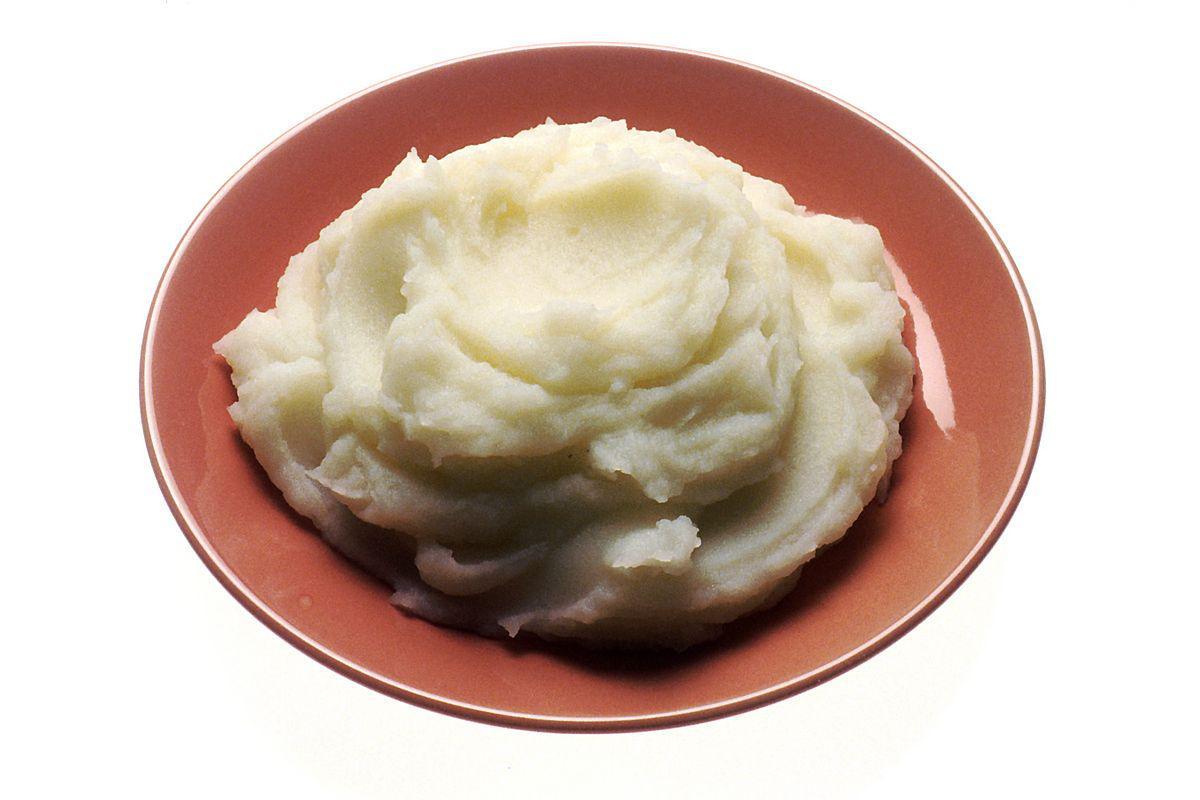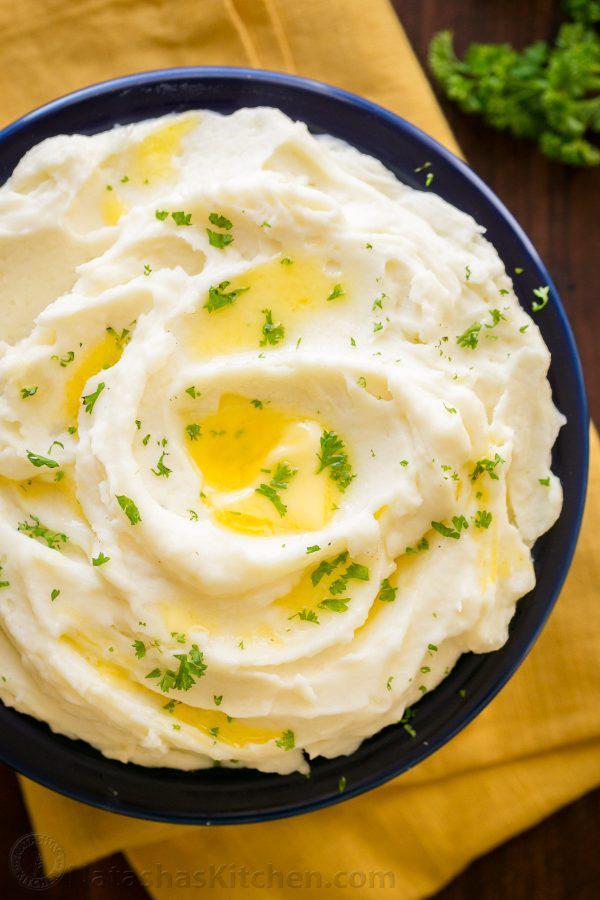The first image is the image on the left, the second image is the image on the right. For the images displayed, is the sentence "The potatoes in one of the images are served a grey bowl." factually correct? Answer yes or no. No. The first image is the image on the left, the second image is the image on the right. Analyze the images presented: Is the assertion "One bowl of potatoes is ungarnished, and the other is topped with a sprinkling of chopped green bits." valid? Answer yes or no. Yes. 